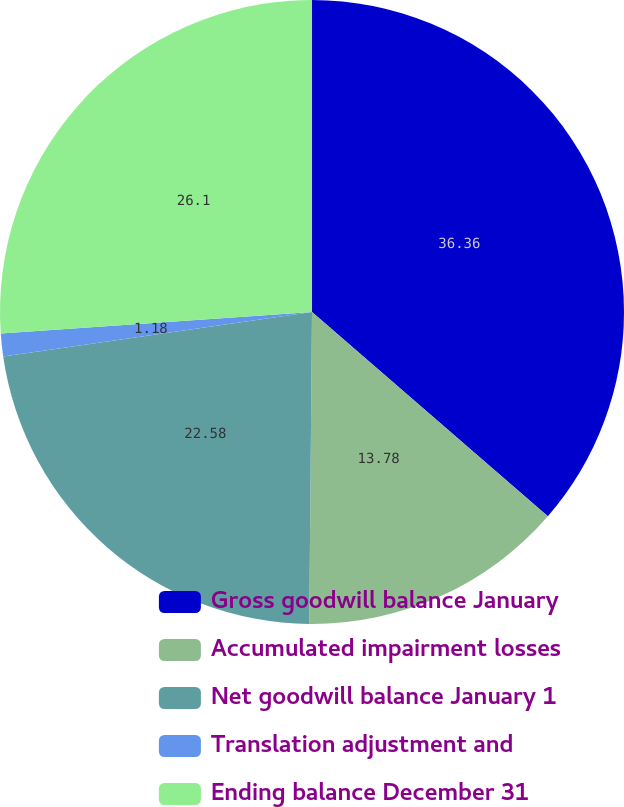<chart> <loc_0><loc_0><loc_500><loc_500><pie_chart><fcel>Gross goodwill balance January<fcel>Accumulated impairment losses<fcel>Net goodwill balance January 1<fcel>Translation adjustment and<fcel>Ending balance December 31<nl><fcel>36.36%<fcel>13.78%<fcel>22.58%<fcel>1.18%<fcel>26.1%<nl></chart> 